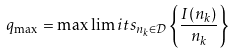Convert formula to latex. <formula><loc_0><loc_0><loc_500><loc_500>q _ { \max } = \max \lim i t s _ { n _ { k } \in \mathcal { D } } \left \{ \frac { I ( n _ { k } ) } { n _ { k } } \right \}</formula> 